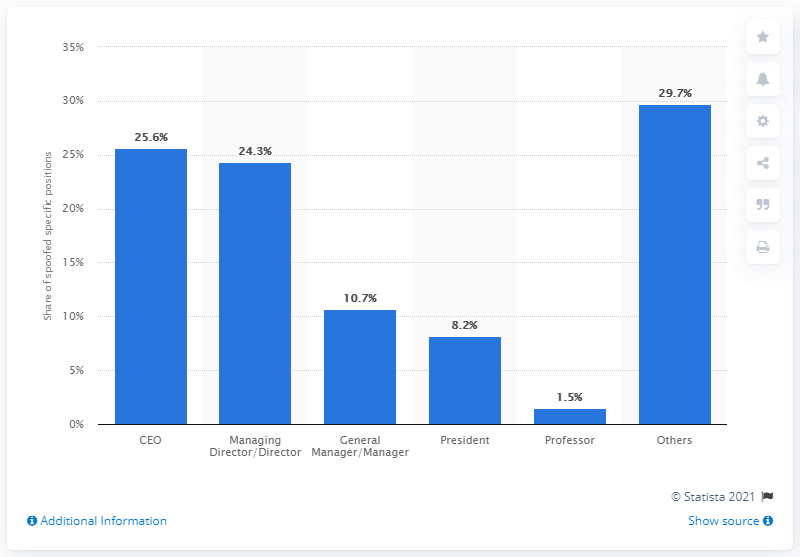Point out several critical features in this image. In the most spoofed position was the CEO. According to research, approximately 25.6% of BEC scammers pretend to be the CEO of their victim's company. 